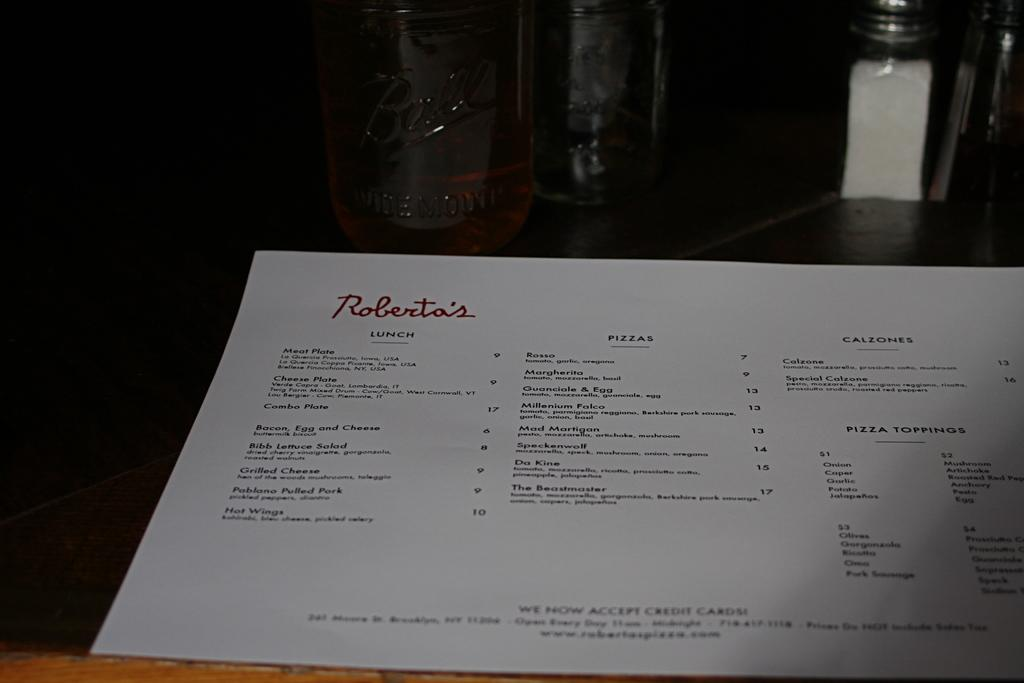Provide a one-sentence caption for the provided image. Menu from Roberta's featuring a lunch section and calzones. 